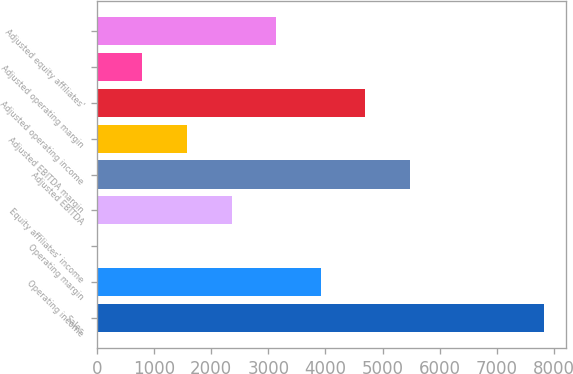<chart> <loc_0><loc_0><loc_500><loc_500><bar_chart><fcel>Sales<fcel>Operating income<fcel>Operating margin<fcel>Equity affiliates' income<fcel>Adjusted EBITDA<fcel>Adjusted EBITDA margin<fcel>Adjusted operating income<fcel>Adjusted operating margin<fcel>Adjusted equity affiliates'<nl><fcel>7824.3<fcel>3920.05<fcel>15.8<fcel>2358.35<fcel>5481.75<fcel>1577.5<fcel>4700.9<fcel>796.65<fcel>3139.2<nl></chart> 